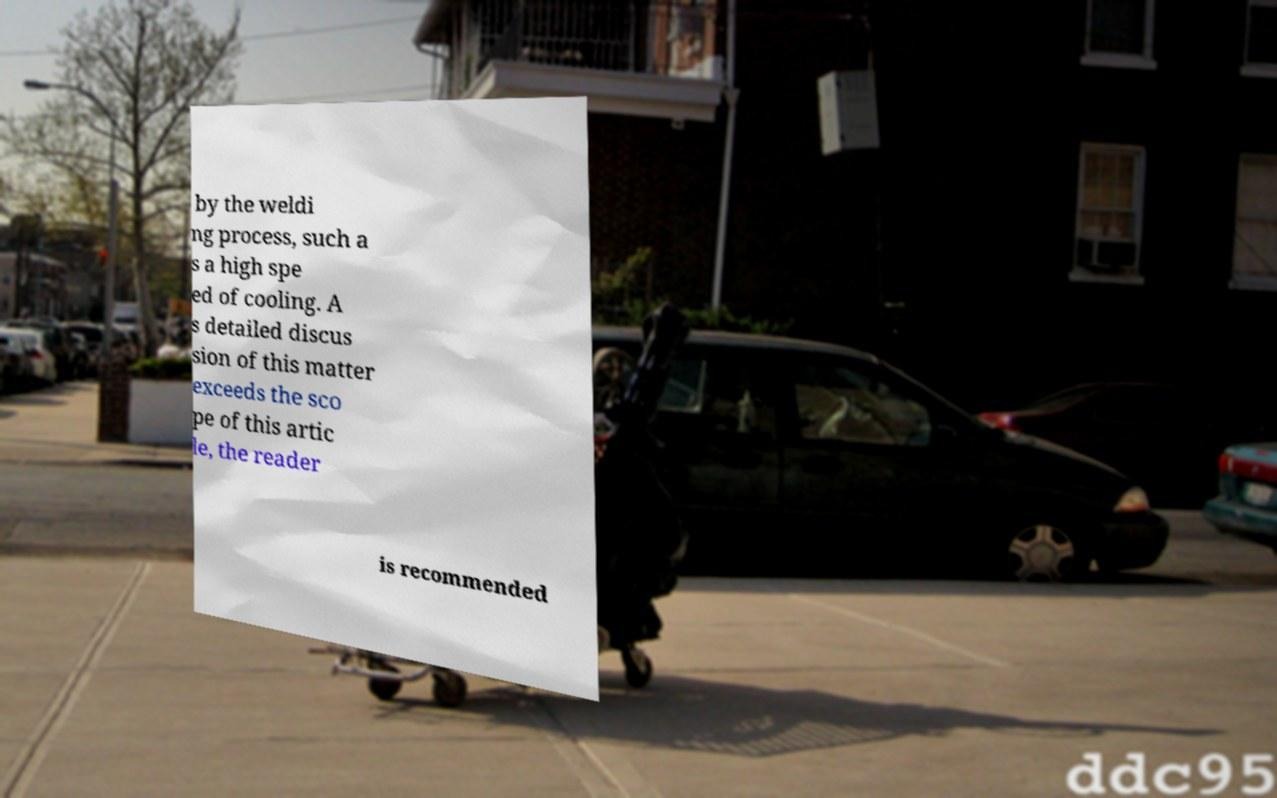Could you assist in decoding the text presented in this image and type it out clearly? by the weldi ng process, such a s a high spe ed of cooling. A s detailed discus sion of this matter exceeds the sco pe of this artic le, the reader is recommended 